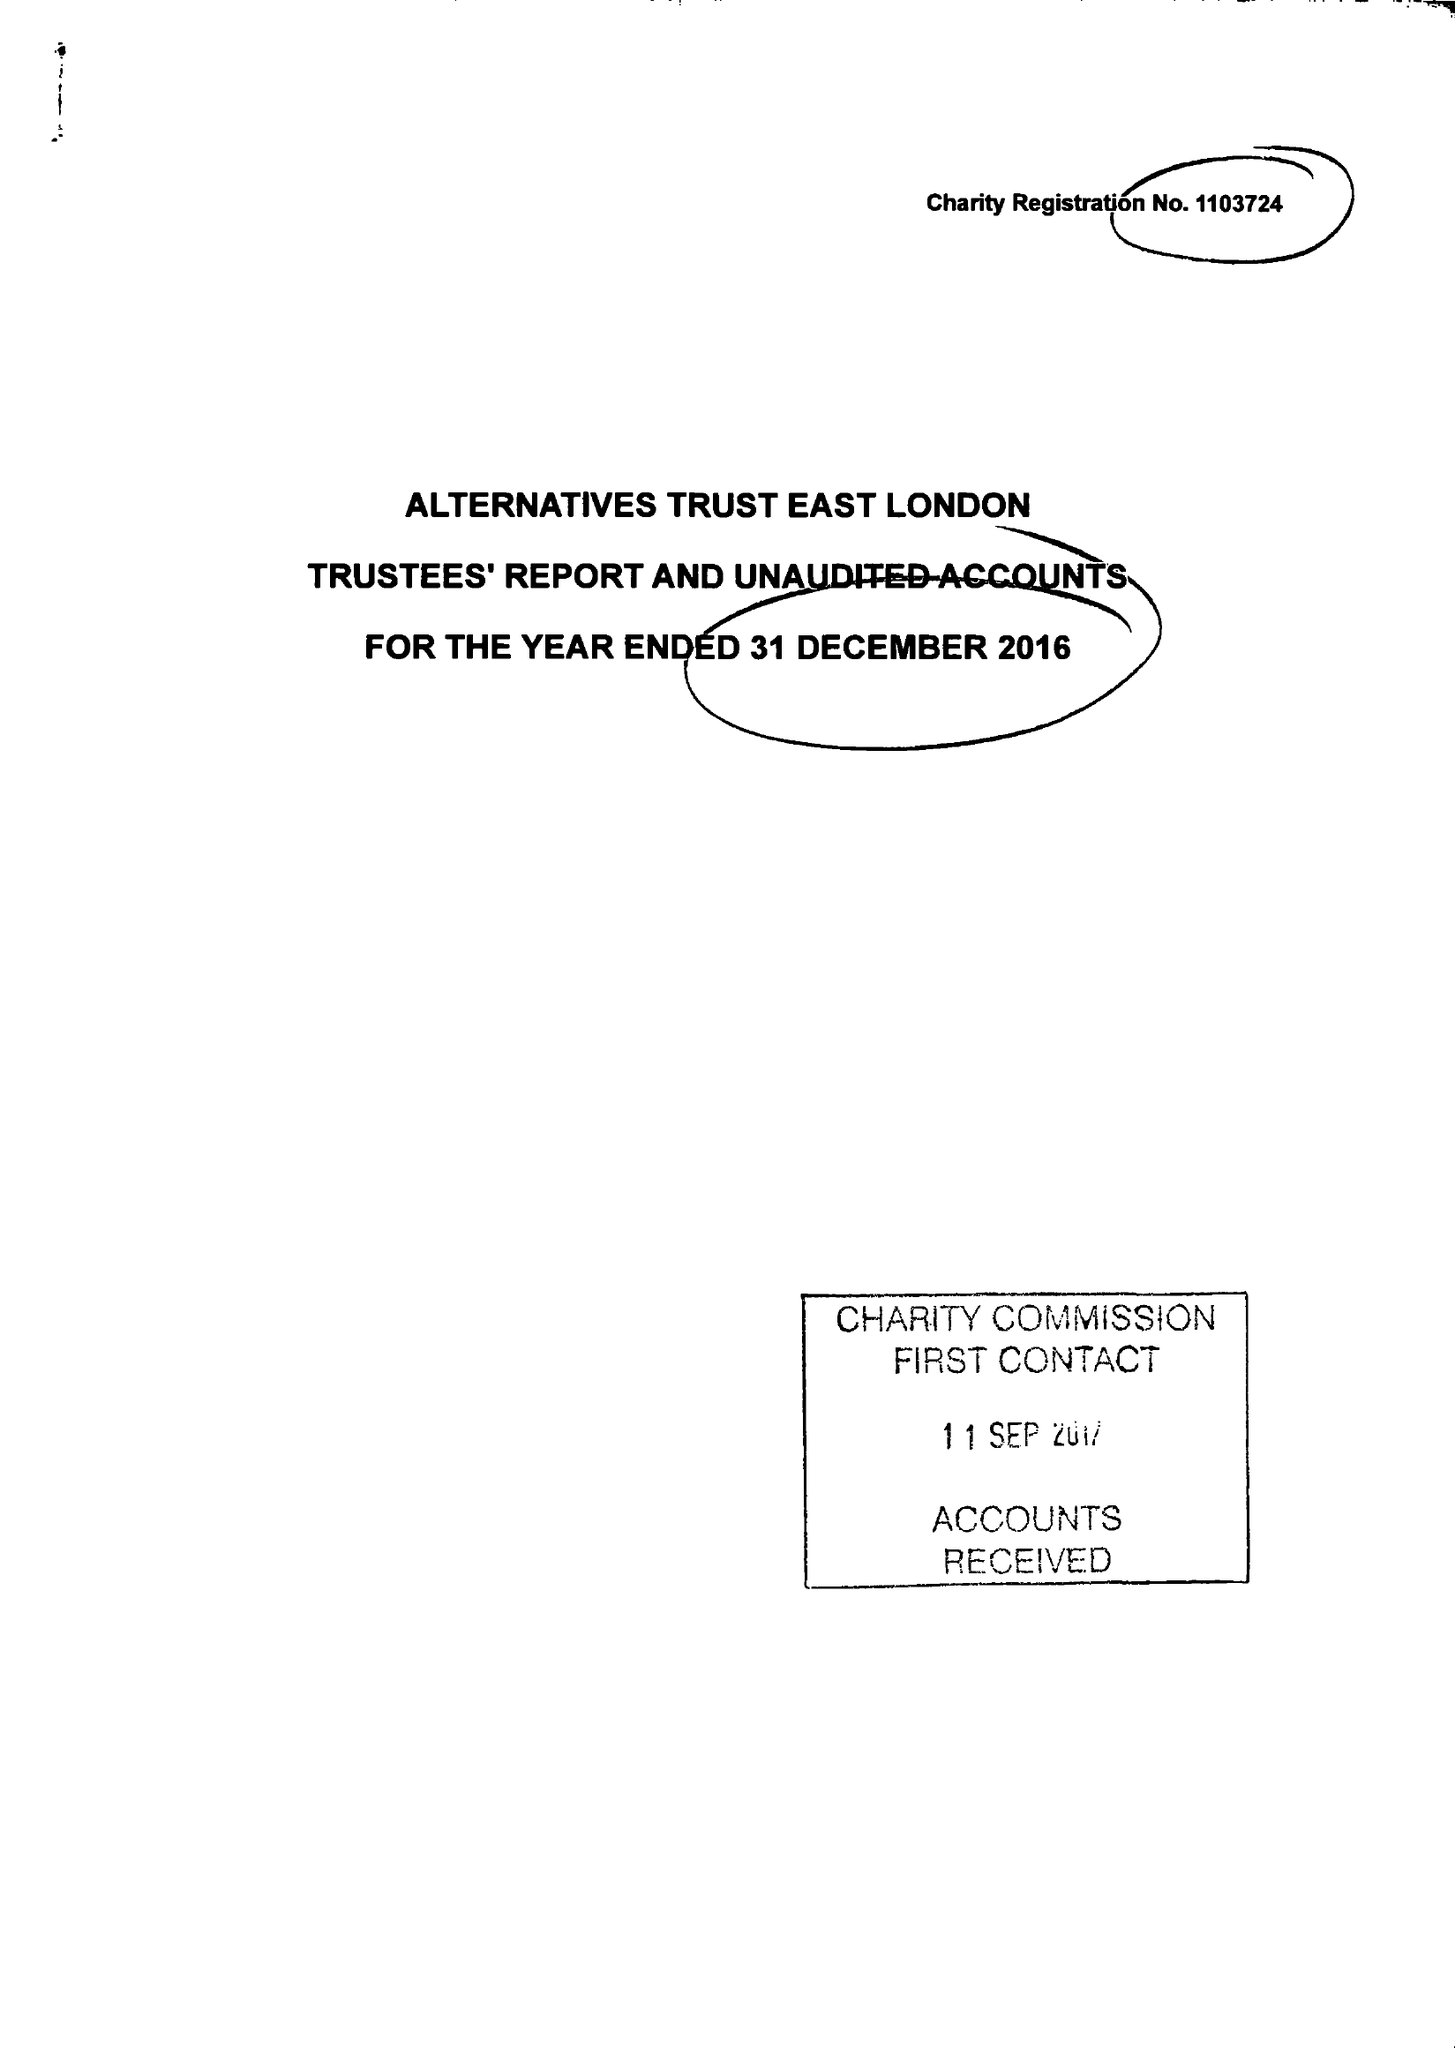What is the value for the charity_number?
Answer the question using a single word or phrase. 1103724 